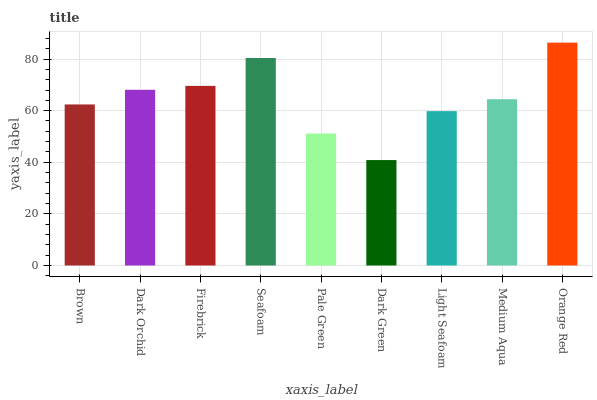Is Dark Orchid the minimum?
Answer yes or no. No. Is Dark Orchid the maximum?
Answer yes or no. No. Is Dark Orchid greater than Brown?
Answer yes or no. Yes. Is Brown less than Dark Orchid?
Answer yes or no. Yes. Is Brown greater than Dark Orchid?
Answer yes or no. No. Is Dark Orchid less than Brown?
Answer yes or no. No. Is Medium Aqua the high median?
Answer yes or no. Yes. Is Medium Aqua the low median?
Answer yes or no. Yes. Is Light Seafoam the high median?
Answer yes or no. No. Is Light Seafoam the low median?
Answer yes or no. No. 